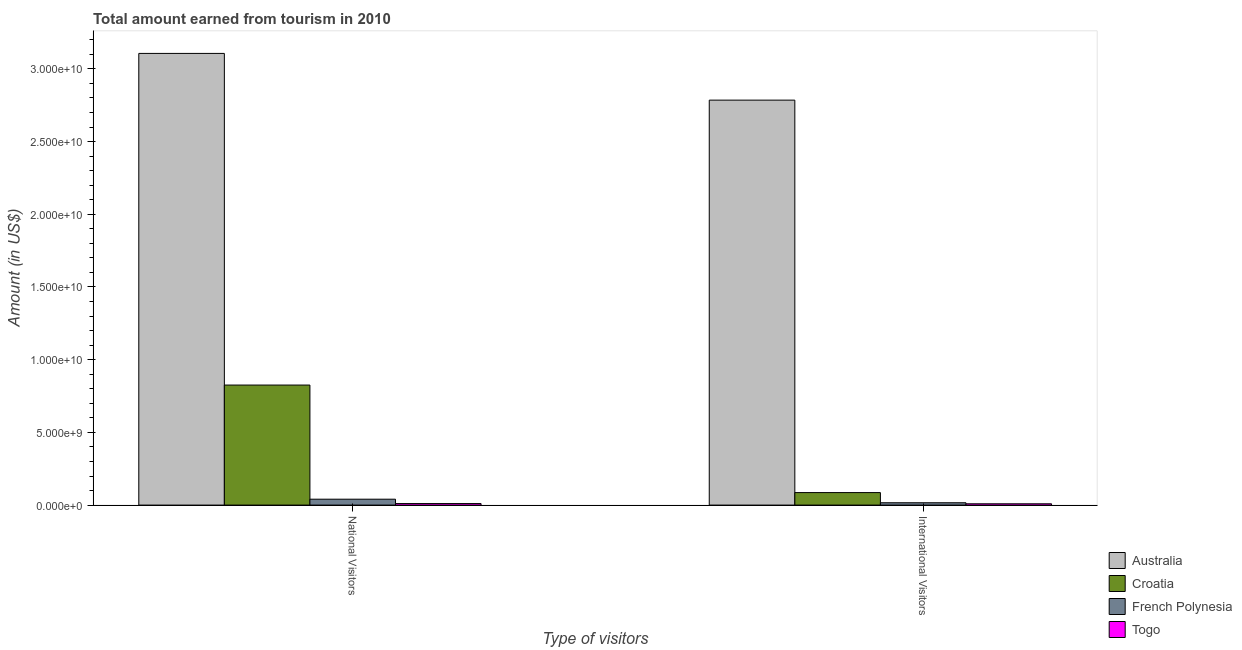How many groups of bars are there?
Offer a very short reply. 2. How many bars are there on the 2nd tick from the right?
Make the answer very short. 4. What is the label of the 1st group of bars from the left?
Your answer should be compact. National Visitors. What is the amount earned from national visitors in Togo?
Provide a succinct answer. 1.05e+08. Across all countries, what is the maximum amount earned from national visitors?
Offer a very short reply. 3.11e+1. Across all countries, what is the minimum amount earned from international visitors?
Offer a very short reply. 8.90e+07. In which country was the amount earned from national visitors minimum?
Provide a short and direct response. Togo. What is the total amount earned from international visitors in the graph?
Provide a succinct answer. 2.90e+1. What is the difference between the amount earned from national visitors in Australia and that in Croatia?
Ensure brevity in your answer.  2.28e+1. What is the difference between the amount earned from national visitors in Croatia and the amount earned from international visitors in French Polynesia?
Offer a very short reply. 8.10e+09. What is the average amount earned from national visitors per country?
Offer a very short reply. 9.96e+09. What is the difference between the amount earned from international visitors and amount earned from national visitors in Australia?
Offer a terse response. -3.21e+09. What is the ratio of the amount earned from international visitors in Togo to that in French Polynesia?
Offer a very short reply. 0.56. What does the 2nd bar from the left in International Visitors represents?
Your answer should be very brief. Croatia. What does the 1st bar from the right in National Visitors represents?
Ensure brevity in your answer.  Togo. How many bars are there?
Your answer should be compact. 8. Are all the bars in the graph horizontal?
Give a very brief answer. No. How many countries are there in the graph?
Your answer should be compact. 4. What is the difference between two consecutive major ticks on the Y-axis?
Provide a succinct answer. 5.00e+09. Does the graph contain any zero values?
Your response must be concise. No. Does the graph contain grids?
Provide a short and direct response. No. How are the legend labels stacked?
Make the answer very short. Vertical. What is the title of the graph?
Provide a succinct answer. Total amount earned from tourism in 2010. What is the label or title of the X-axis?
Give a very brief answer. Type of visitors. What is the Amount (in US$) in Australia in National Visitors?
Your response must be concise. 3.11e+1. What is the Amount (in US$) of Croatia in National Visitors?
Your answer should be compact. 8.26e+09. What is the Amount (in US$) of French Polynesia in National Visitors?
Keep it short and to the point. 4.05e+08. What is the Amount (in US$) of Togo in National Visitors?
Your response must be concise. 1.05e+08. What is the Amount (in US$) of Australia in International Visitors?
Your answer should be compact. 2.79e+1. What is the Amount (in US$) in Croatia in International Visitors?
Provide a short and direct response. 8.59e+08. What is the Amount (in US$) in French Polynesia in International Visitors?
Offer a terse response. 1.60e+08. What is the Amount (in US$) of Togo in International Visitors?
Provide a succinct answer. 8.90e+07. Across all Type of visitors, what is the maximum Amount (in US$) of Australia?
Provide a succinct answer. 3.11e+1. Across all Type of visitors, what is the maximum Amount (in US$) of Croatia?
Give a very brief answer. 8.26e+09. Across all Type of visitors, what is the maximum Amount (in US$) in French Polynesia?
Offer a very short reply. 4.05e+08. Across all Type of visitors, what is the maximum Amount (in US$) in Togo?
Your response must be concise. 1.05e+08. Across all Type of visitors, what is the minimum Amount (in US$) of Australia?
Offer a terse response. 2.79e+1. Across all Type of visitors, what is the minimum Amount (in US$) in Croatia?
Your answer should be compact. 8.59e+08. Across all Type of visitors, what is the minimum Amount (in US$) of French Polynesia?
Give a very brief answer. 1.60e+08. Across all Type of visitors, what is the minimum Amount (in US$) of Togo?
Provide a succinct answer. 8.90e+07. What is the total Amount (in US$) of Australia in the graph?
Provide a succinct answer. 5.89e+1. What is the total Amount (in US$) in Croatia in the graph?
Offer a terse response. 9.11e+09. What is the total Amount (in US$) of French Polynesia in the graph?
Give a very brief answer. 5.65e+08. What is the total Amount (in US$) of Togo in the graph?
Your response must be concise. 1.94e+08. What is the difference between the Amount (in US$) of Australia in National Visitors and that in International Visitors?
Your response must be concise. 3.21e+09. What is the difference between the Amount (in US$) of Croatia in National Visitors and that in International Visitors?
Keep it short and to the point. 7.40e+09. What is the difference between the Amount (in US$) in French Polynesia in National Visitors and that in International Visitors?
Ensure brevity in your answer.  2.45e+08. What is the difference between the Amount (in US$) in Togo in National Visitors and that in International Visitors?
Make the answer very short. 1.60e+07. What is the difference between the Amount (in US$) in Australia in National Visitors and the Amount (in US$) in Croatia in International Visitors?
Your response must be concise. 3.02e+1. What is the difference between the Amount (in US$) in Australia in National Visitors and the Amount (in US$) in French Polynesia in International Visitors?
Your answer should be very brief. 3.09e+1. What is the difference between the Amount (in US$) in Australia in National Visitors and the Amount (in US$) in Togo in International Visitors?
Make the answer very short. 3.10e+1. What is the difference between the Amount (in US$) in Croatia in National Visitors and the Amount (in US$) in French Polynesia in International Visitors?
Ensure brevity in your answer.  8.10e+09. What is the difference between the Amount (in US$) of Croatia in National Visitors and the Amount (in US$) of Togo in International Visitors?
Provide a succinct answer. 8.17e+09. What is the difference between the Amount (in US$) of French Polynesia in National Visitors and the Amount (in US$) of Togo in International Visitors?
Your answer should be compact. 3.16e+08. What is the average Amount (in US$) in Australia per Type of visitors?
Give a very brief answer. 2.95e+1. What is the average Amount (in US$) of Croatia per Type of visitors?
Keep it short and to the point. 4.56e+09. What is the average Amount (in US$) of French Polynesia per Type of visitors?
Your answer should be very brief. 2.82e+08. What is the average Amount (in US$) in Togo per Type of visitors?
Offer a terse response. 9.70e+07. What is the difference between the Amount (in US$) of Australia and Amount (in US$) of Croatia in National Visitors?
Make the answer very short. 2.28e+1. What is the difference between the Amount (in US$) in Australia and Amount (in US$) in French Polynesia in National Visitors?
Offer a very short reply. 3.07e+1. What is the difference between the Amount (in US$) of Australia and Amount (in US$) of Togo in National Visitors?
Make the answer very short. 3.10e+1. What is the difference between the Amount (in US$) of Croatia and Amount (in US$) of French Polynesia in National Visitors?
Make the answer very short. 7.85e+09. What is the difference between the Amount (in US$) of Croatia and Amount (in US$) of Togo in National Visitors?
Offer a terse response. 8.15e+09. What is the difference between the Amount (in US$) in French Polynesia and Amount (in US$) in Togo in National Visitors?
Make the answer very short. 3.00e+08. What is the difference between the Amount (in US$) in Australia and Amount (in US$) in Croatia in International Visitors?
Ensure brevity in your answer.  2.70e+1. What is the difference between the Amount (in US$) of Australia and Amount (in US$) of French Polynesia in International Visitors?
Keep it short and to the point. 2.77e+1. What is the difference between the Amount (in US$) in Australia and Amount (in US$) in Togo in International Visitors?
Give a very brief answer. 2.78e+1. What is the difference between the Amount (in US$) of Croatia and Amount (in US$) of French Polynesia in International Visitors?
Your answer should be compact. 6.99e+08. What is the difference between the Amount (in US$) of Croatia and Amount (in US$) of Togo in International Visitors?
Give a very brief answer. 7.70e+08. What is the difference between the Amount (in US$) of French Polynesia and Amount (in US$) of Togo in International Visitors?
Ensure brevity in your answer.  7.10e+07. What is the ratio of the Amount (in US$) in Australia in National Visitors to that in International Visitors?
Make the answer very short. 1.12. What is the ratio of the Amount (in US$) of Croatia in National Visitors to that in International Visitors?
Make the answer very short. 9.61. What is the ratio of the Amount (in US$) in French Polynesia in National Visitors to that in International Visitors?
Provide a short and direct response. 2.53. What is the ratio of the Amount (in US$) of Togo in National Visitors to that in International Visitors?
Provide a succinct answer. 1.18. What is the difference between the highest and the second highest Amount (in US$) of Australia?
Give a very brief answer. 3.21e+09. What is the difference between the highest and the second highest Amount (in US$) of Croatia?
Offer a very short reply. 7.40e+09. What is the difference between the highest and the second highest Amount (in US$) in French Polynesia?
Your answer should be compact. 2.45e+08. What is the difference between the highest and the second highest Amount (in US$) of Togo?
Provide a succinct answer. 1.60e+07. What is the difference between the highest and the lowest Amount (in US$) of Australia?
Offer a terse response. 3.21e+09. What is the difference between the highest and the lowest Amount (in US$) of Croatia?
Your answer should be compact. 7.40e+09. What is the difference between the highest and the lowest Amount (in US$) of French Polynesia?
Ensure brevity in your answer.  2.45e+08. What is the difference between the highest and the lowest Amount (in US$) of Togo?
Your answer should be compact. 1.60e+07. 